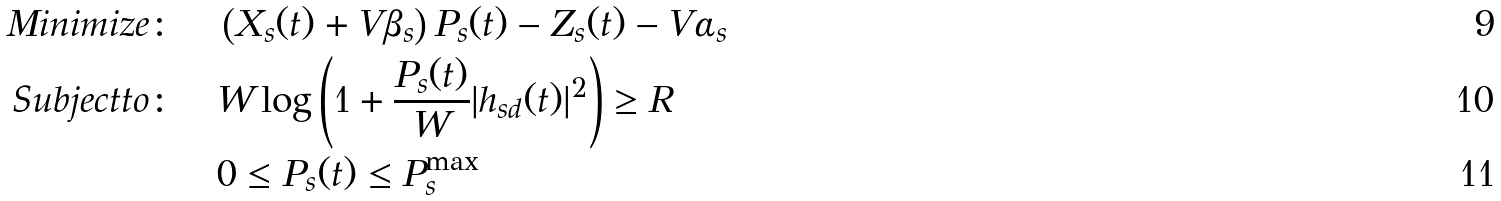<formula> <loc_0><loc_0><loc_500><loc_500>M i n i m i z e \colon \quad & \left ( X _ { s } ( t ) + V \beta _ { s } \right ) { P _ { s } ( t ) } - Z _ { s } ( t ) - V \alpha _ { s } \\ S u b j e c t t o \colon \quad & { W } \log \left ( 1 + \frac { P _ { s } ( t ) } { W } | h _ { s d } ( t ) | ^ { 2 } \right ) \geq R \\ & 0 \leq P _ { s } ( t ) \leq P _ { s } ^ { \max }</formula> 